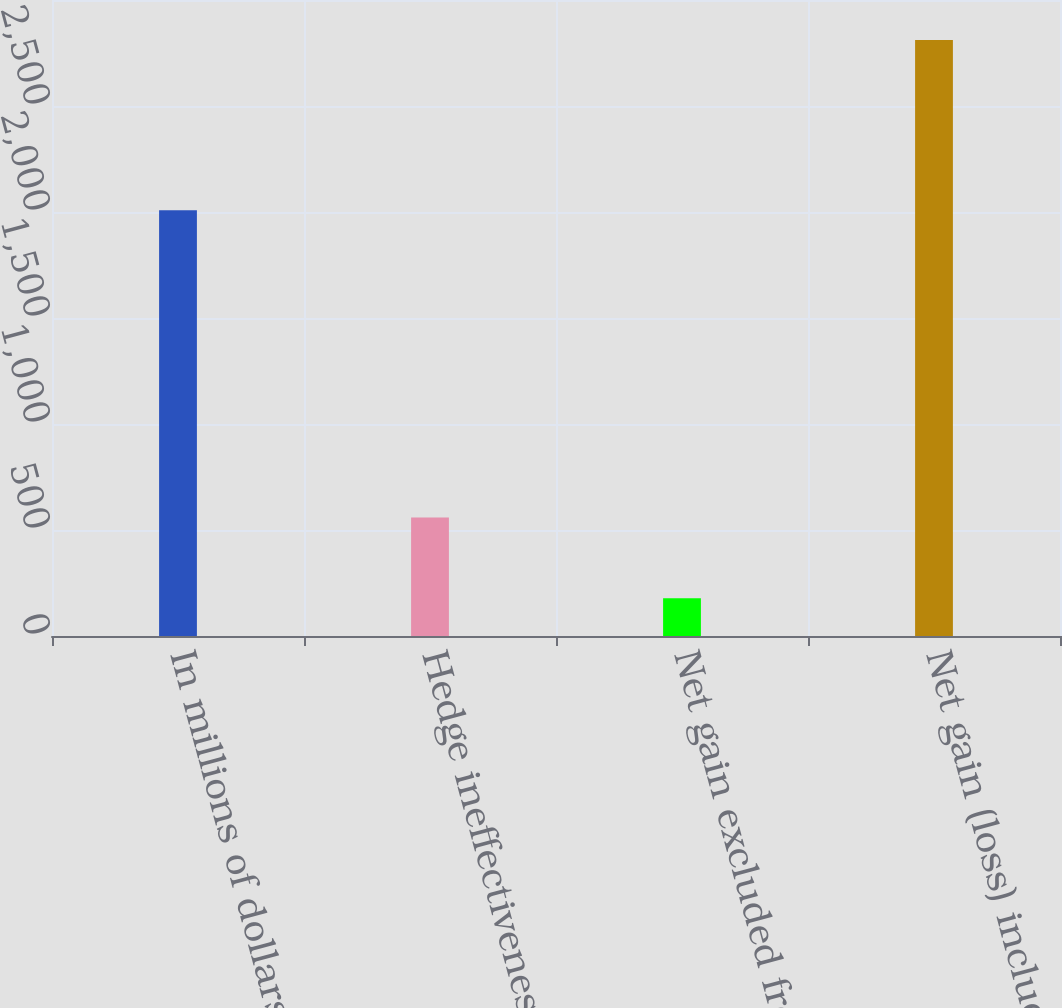<chart> <loc_0><loc_0><loc_500><loc_500><bar_chart><fcel>In millions of dollars<fcel>Hedge ineffectiveness<fcel>Net gain excluded from<fcel>Net gain (loss) included in<nl><fcel>2008<fcel>559<fcel>178<fcel>2811<nl></chart> 